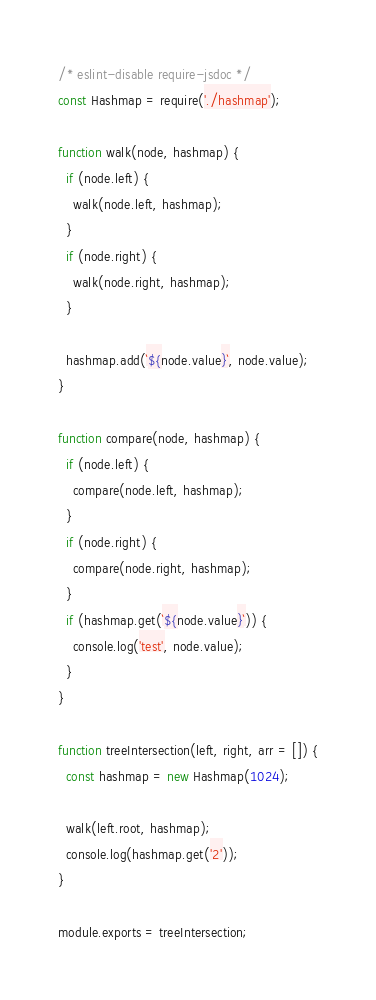<code> <loc_0><loc_0><loc_500><loc_500><_JavaScript_>/* eslint-disable require-jsdoc */
const Hashmap = require('./hashmap');

function walk(node, hashmap) {
  if (node.left) {
    walk(node.left, hashmap);
  }
  if (node.right) {
    walk(node.right, hashmap);
  }

  hashmap.add(`${node.value}`, node.value);
}

function compare(node, hashmap) {
  if (node.left) {
    compare(node.left, hashmap);
  }
  if (node.right) {
    compare(node.right, hashmap);
  }
  if (hashmap.get(`${node.value}`)) {
    console.log('test', node.value);
  }
}

function treeIntersection(left, right, arr = []) {
  const hashmap = new Hashmap(1024);

  walk(left.root, hashmap);
  console.log(hashmap.get('2'));
}

module.exports = treeIntersection;
</code> 